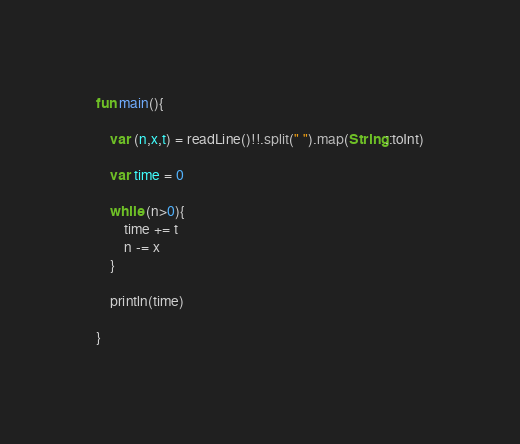<code> <loc_0><loc_0><loc_500><loc_500><_Kotlin_>fun main(){

    var (n,x,t) = readLine()!!.split(" ").map(String::toInt)

    var time = 0

    while (n>0){
        time += t
        n -= x
    }

    println(time)

}</code> 